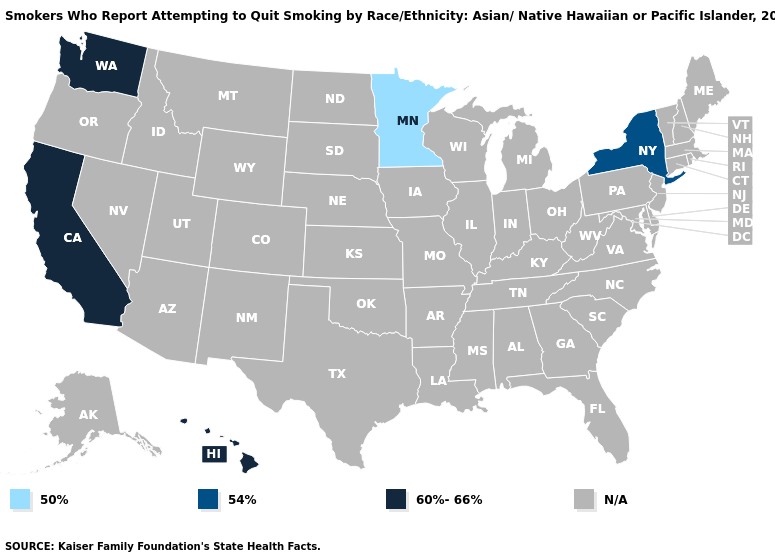Which states hav the highest value in the West?
Be succinct. California, Hawaii, Washington. Among the states that border Arizona , which have the lowest value?
Short answer required. California. What is the value of Indiana?
Give a very brief answer. N/A. Which states have the lowest value in the MidWest?
Concise answer only. Minnesota. Name the states that have a value in the range 50%?
Write a very short answer. Minnesota. Name the states that have a value in the range N/A?
Keep it brief. Alabama, Alaska, Arizona, Arkansas, Colorado, Connecticut, Delaware, Florida, Georgia, Idaho, Illinois, Indiana, Iowa, Kansas, Kentucky, Louisiana, Maine, Maryland, Massachusetts, Michigan, Mississippi, Missouri, Montana, Nebraska, Nevada, New Hampshire, New Jersey, New Mexico, North Carolina, North Dakota, Ohio, Oklahoma, Oregon, Pennsylvania, Rhode Island, South Carolina, South Dakota, Tennessee, Texas, Utah, Vermont, Virginia, West Virginia, Wisconsin, Wyoming. Name the states that have a value in the range 54%?
Write a very short answer. New York. Name the states that have a value in the range 50%?
Short answer required. Minnesota. What is the value of Kentucky?
Keep it brief. N/A. What is the value of Oklahoma?
Give a very brief answer. N/A. Does Minnesota have the highest value in the USA?
Short answer required. No. 